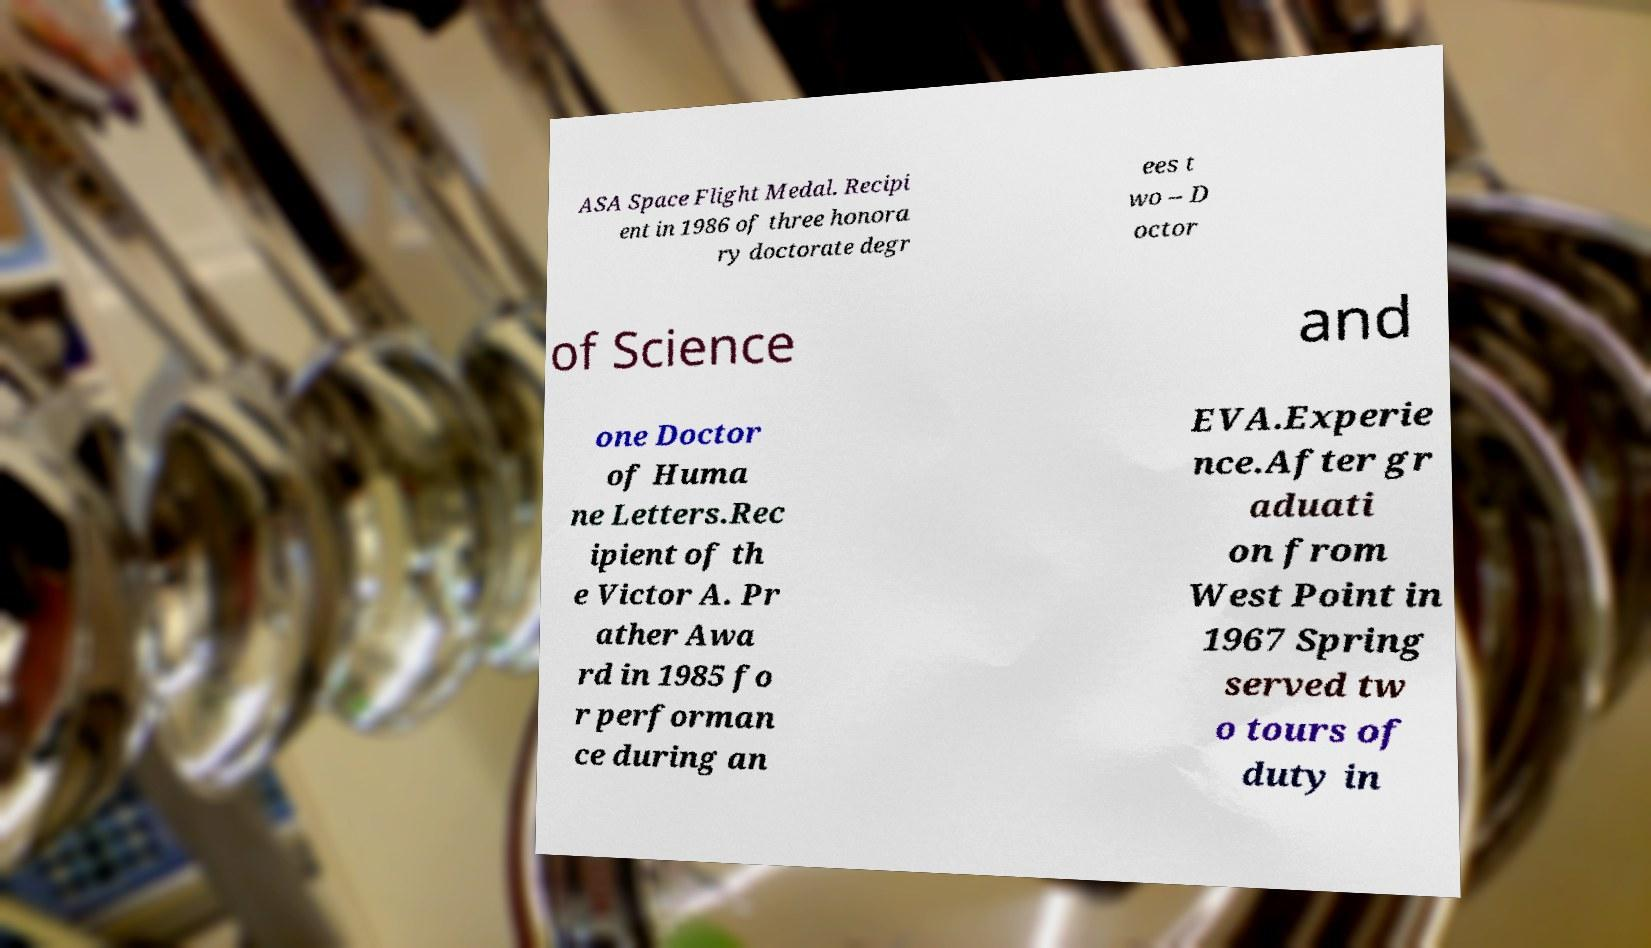Please read and relay the text visible in this image. What does it say? ASA Space Flight Medal. Recipi ent in 1986 of three honora ry doctorate degr ees t wo – D octor of Science and one Doctor of Huma ne Letters.Rec ipient of th e Victor A. Pr ather Awa rd in 1985 fo r performan ce during an EVA.Experie nce.After gr aduati on from West Point in 1967 Spring served tw o tours of duty in 